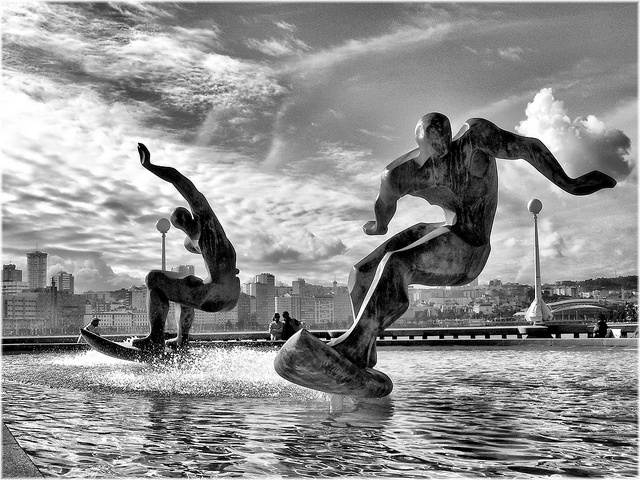Describe the objects in this image and their specific colors. I can see surfboard in white, black, gray, darkgray, and lightgray tones, surfboard in white, black, gray, darkgray, and gainsboro tones, people in white, black, gray, darkgray, and lightgray tones, people in white, black, gray, darkgray, and lightgray tones, and people in white, black, gray, darkgray, and lightgray tones in this image. 